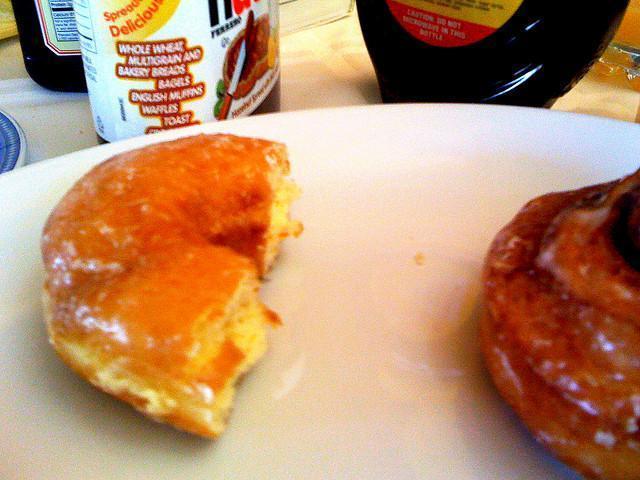How many donuts are there?
Give a very brief answer. 2. How many bottles are in the photo?
Give a very brief answer. 3. How many people are wearing glasses?
Give a very brief answer. 0. 